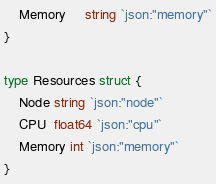<code> <loc_0><loc_0><loc_500><loc_500><_Go_>	Memory     string `json:"memory"`
}

type Resources struct {
	Node string `json:"node"`
	CPU  float64 `json:"cpu"`
	Memory int `json:"memory"`
}</code> 